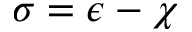Convert formula to latex. <formula><loc_0><loc_0><loc_500><loc_500>\sigma = \epsilon - \chi</formula> 